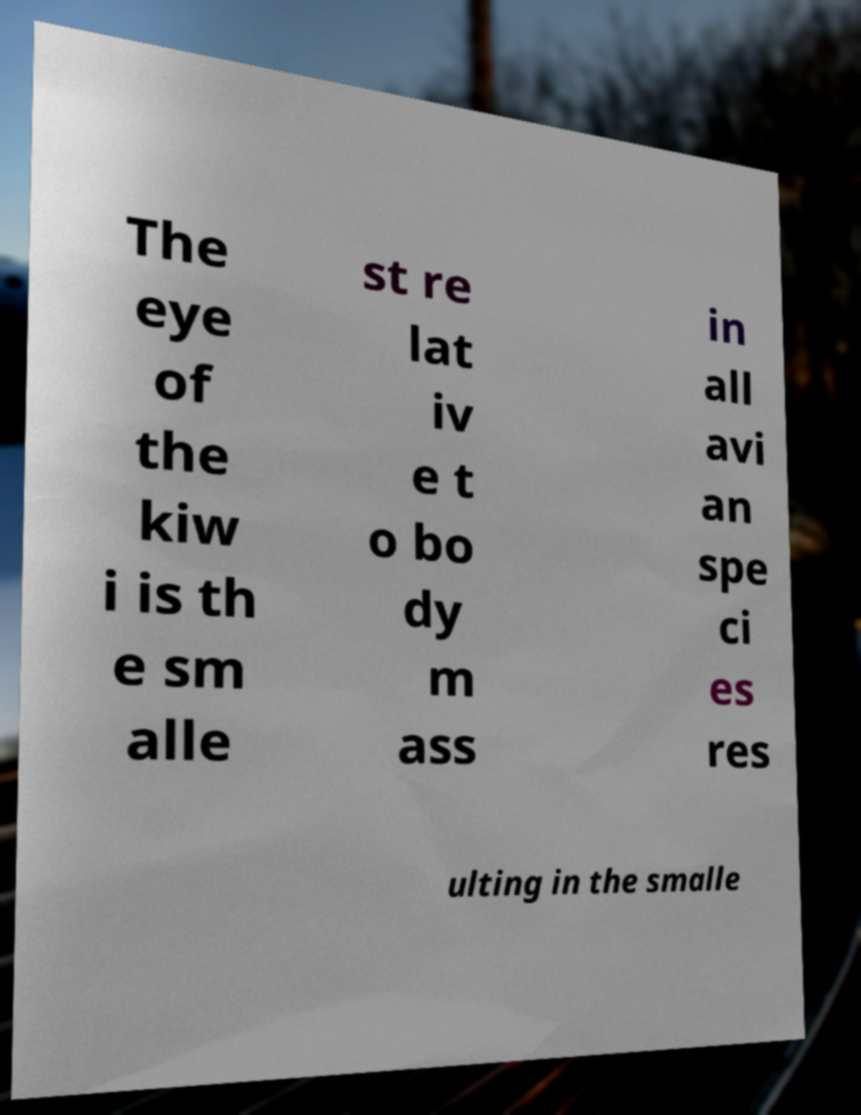Could you extract and type out the text from this image? The eye of the kiw i is th e sm alle st re lat iv e t o bo dy m ass in all avi an spe ci es res ulting in the smalle 